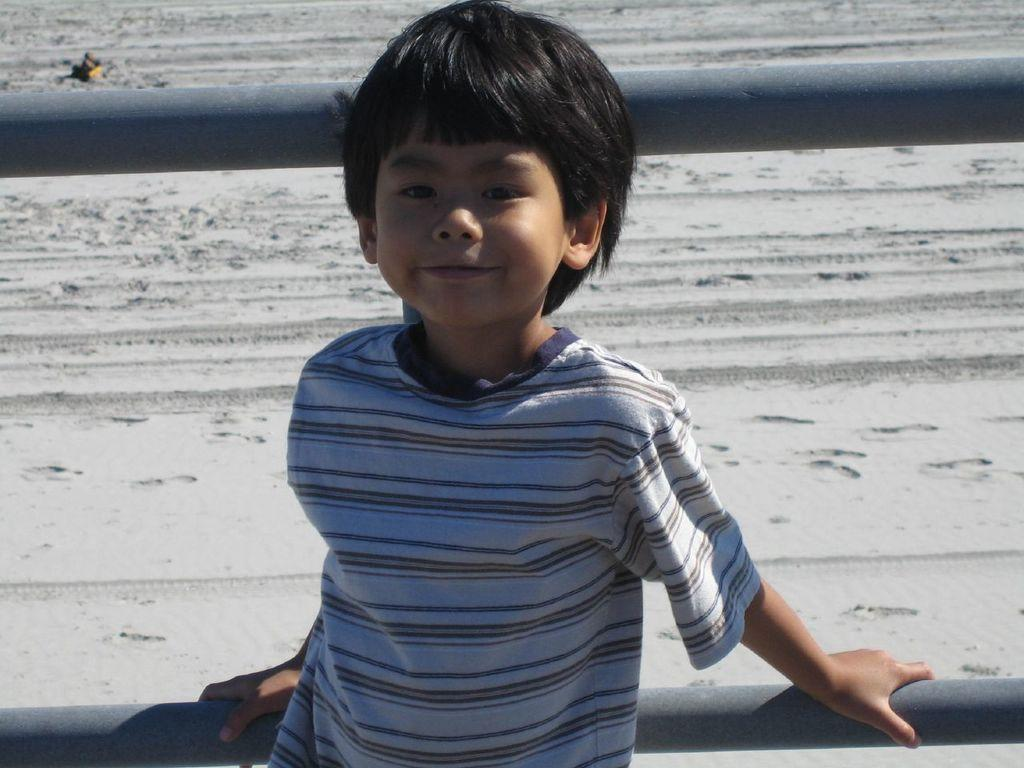What is the main subject of the image? There is a child in the image. What is the child doing in the image? The child is standing and smiling. What can be seen in the background of the image? There is a railing visible in the image. What type of surface is the child standing on? The ground is covered with sand. What type of suit is the child wearing in the image? There is no suit visible in the image; the child is not wearing any clothing mentioned in the facts. Can you tell me what hospital the child is in based on the image? There is no hospital present in the image, nor is there any indication that the child is in a hospital setting. 